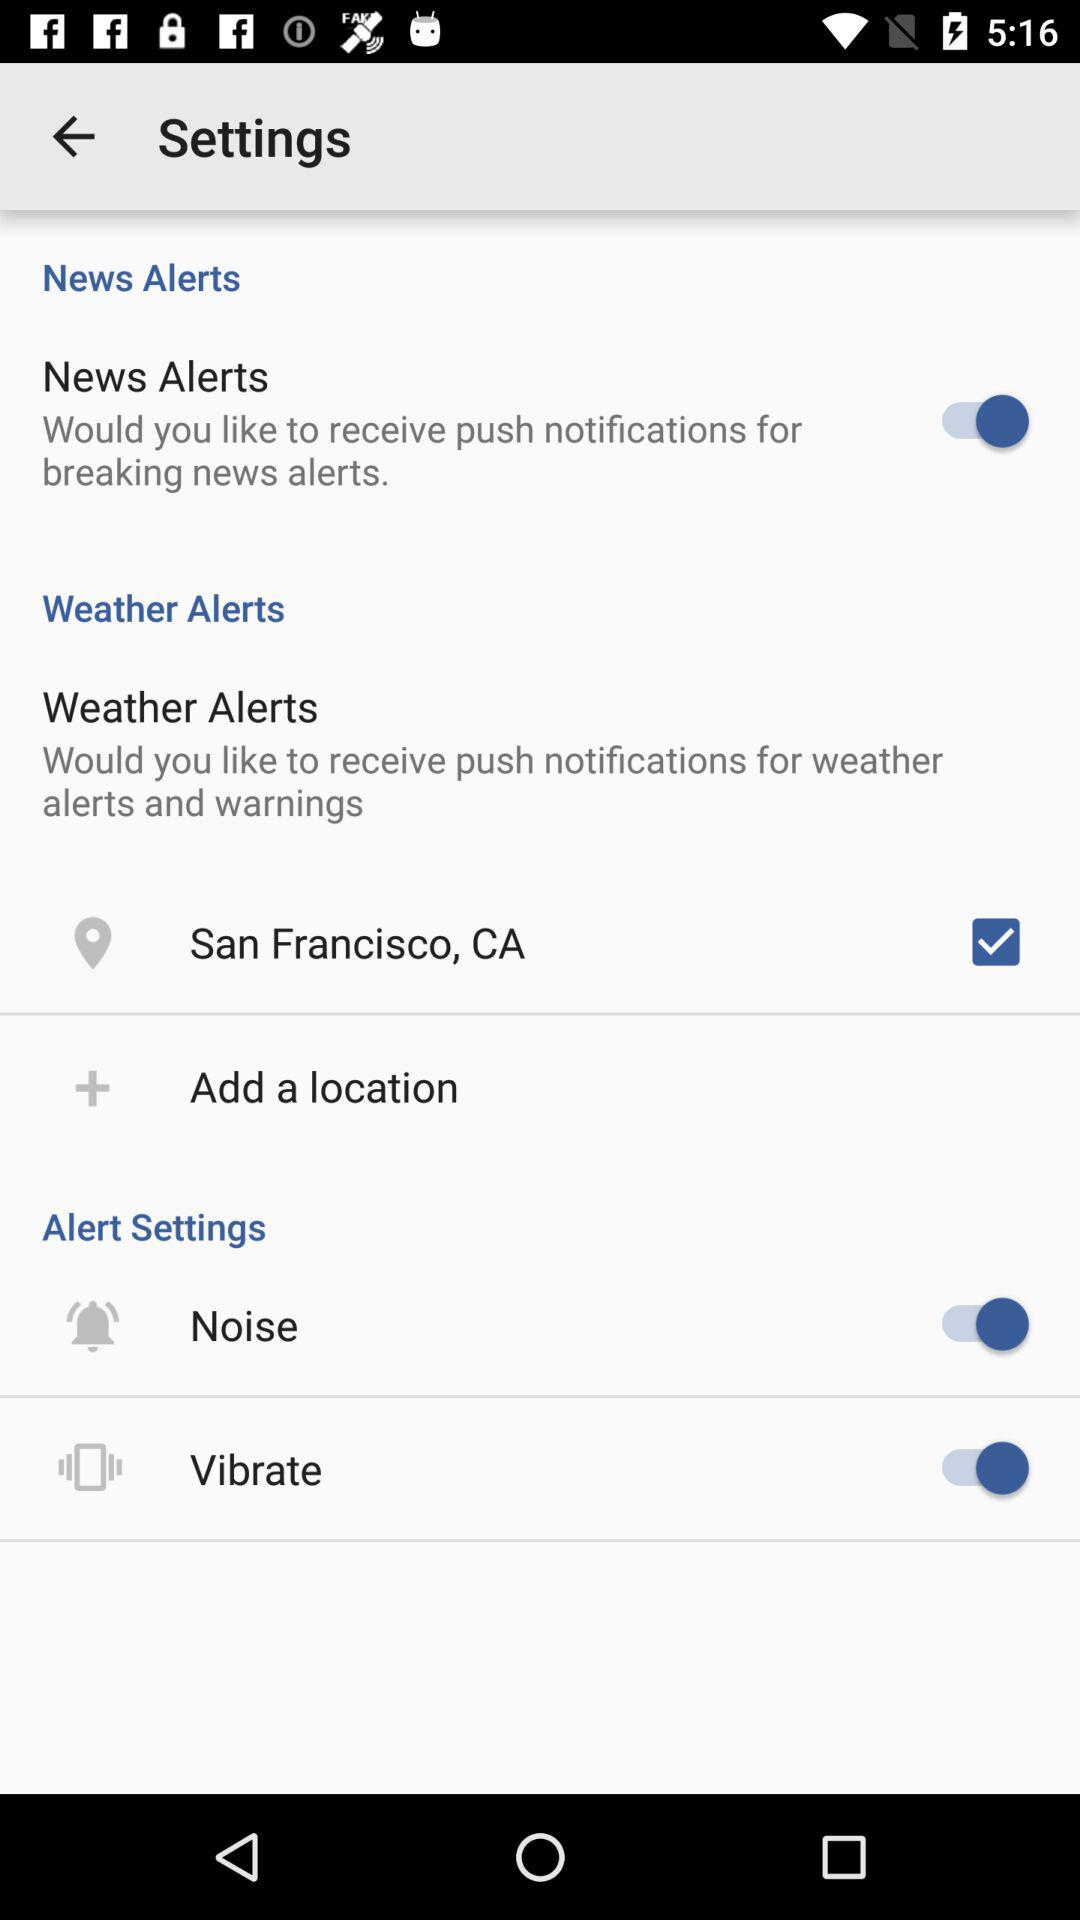What is the status of the news alert? The status is on. 